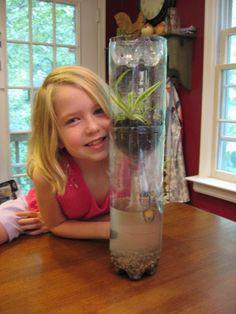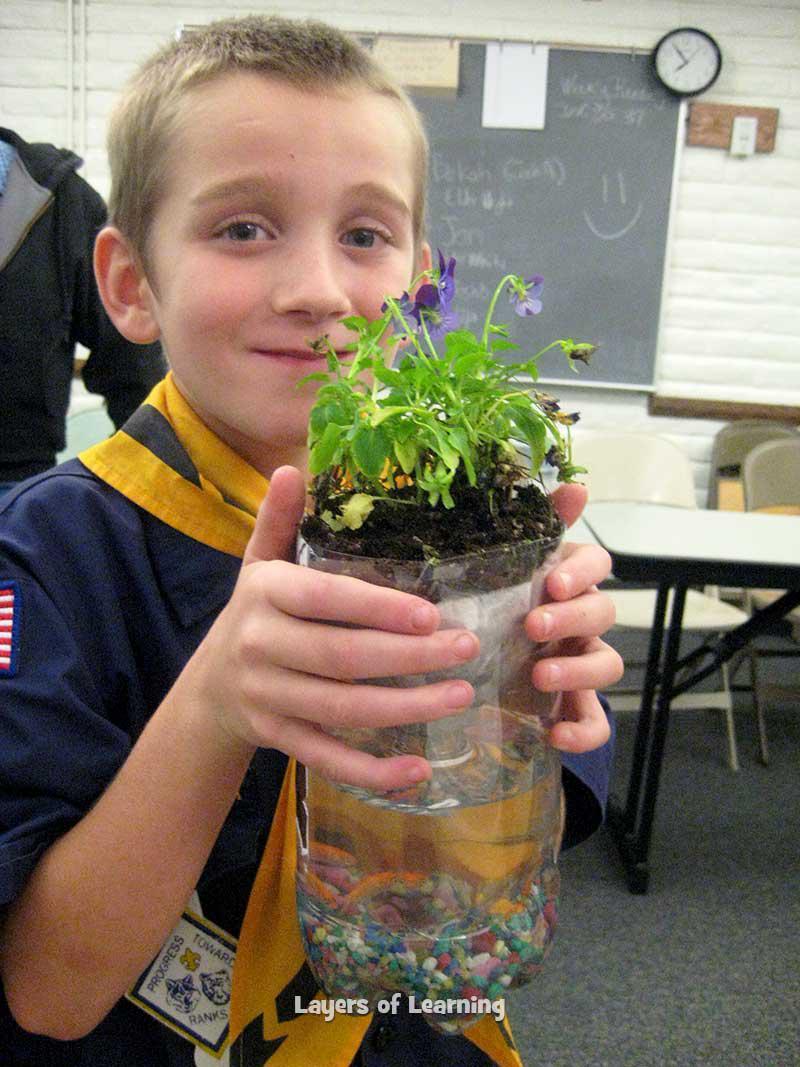The first image is the image on the left, the second image is the image on the right. For the images shown, is this caption "In one image a boy in a uniform is holding up a green plant in front of him with both hands." true? Answer yes or no. Yes. The first image is the image on the left, the second image is the image on the right. Given the left and right images, does the statement "One person is holding a plant." hold true? Answer yes or no. Yes. 